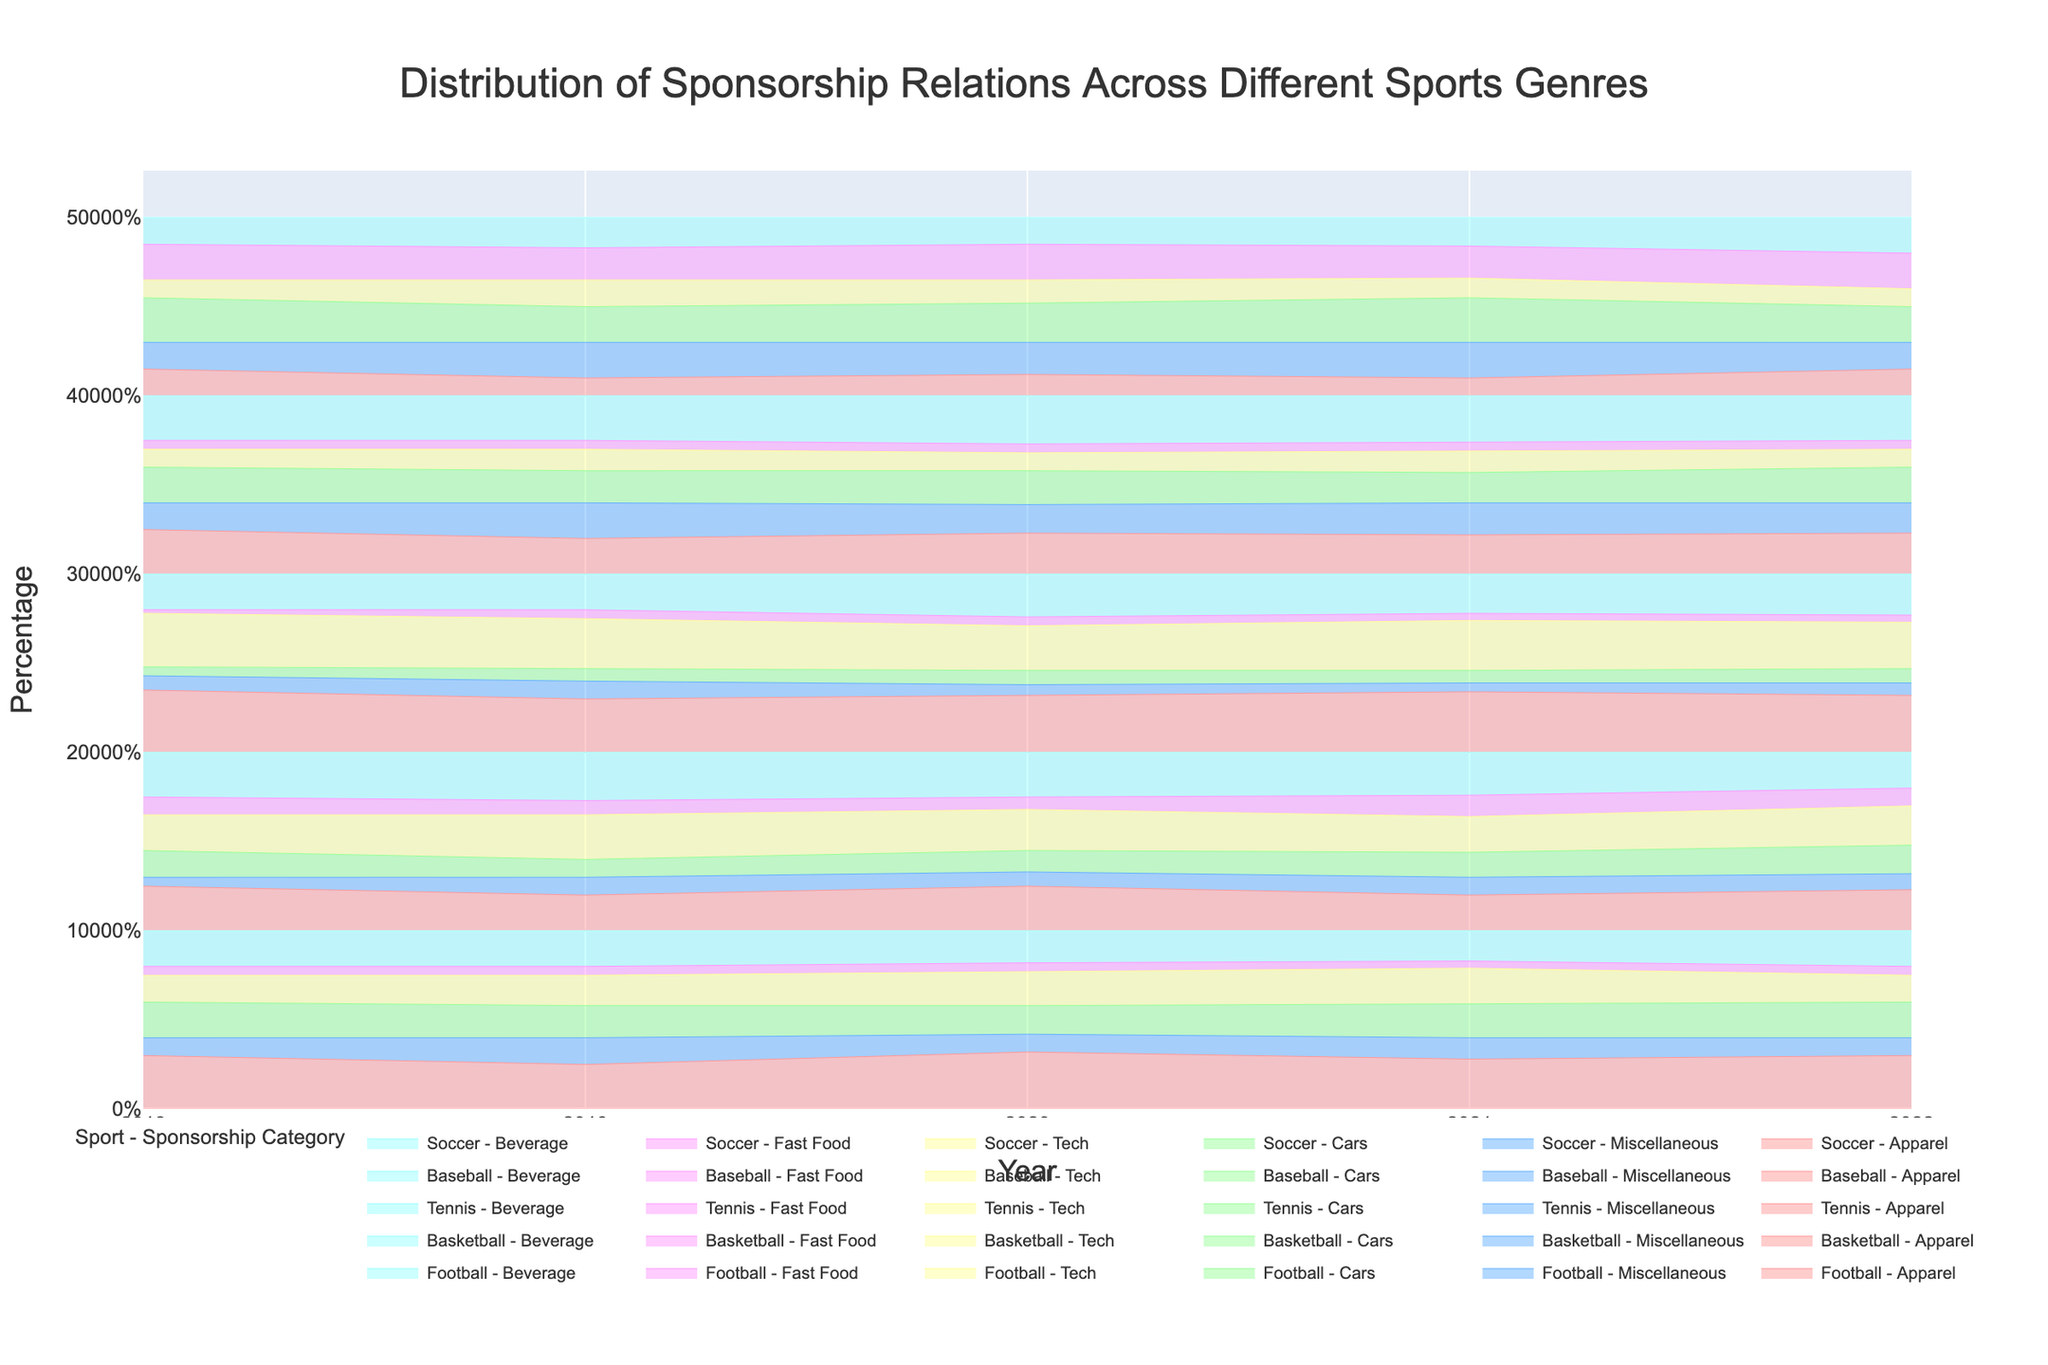How many different sponsorship categories are represented in the plot? The title mentions "Distribution of Sponsorship Relations Across Different Sports Genres," and in the plot, there are clearly several distinct colored areas stacked on top of each other. The legend will typically indicate how many categories are present, which are: Apparel, Miscellaneous, Cars, Tech, Fast Food, and Beverage.
Answer: 6 Which sport had the highest proportion of 'Tech' sponsorship in 2019? By examining the plot, locate the segments corresponding to 'Tech' sponsorship for each sport in 2019. Verify which sport's 'Tech' segment reaches the highest point on the stacked area chart.
Answer: Basketball How did the proportion of 'Apparel' sponsorship in Tennis change from 2018 to 2022? Find the 'Apparel' layers for Tennis in 2018 and 2022 on the plot and compare their heights. The visual stacking will show whether it increased, decreased, or remained the same.
Answer: Decreased What is the general trend in 'Fast Food' sponsorship across all sports between 2018 and 2022? Observe the 'Fast Food' layers across all sports over the years 2018 to 2022. Determine if there is an overall increasing, decreasing, or stable trend. Sum up the proportions for an aggregated view if necessary.
Answer: Relatively stable Comparing Football and Soccer, which sport generally had a higher proportion of 'Cars' sponsorship from 2018 to 2022? Review the 'Cars' layers of both Football and Soccer for each year from 2018 to 2022. Summarize the proportions visually to identify which sport has larger 'Cars' segments overall.
Answer: Soccer In which year did Baseball experience the highest proportion of 'Miscellaneous' sponsorship? Inspect the 'Miscellaneous' sponsorship layer for Baseball across all years and identify the peak proportion.
Answer: 2019 Did 'Beverage' sponsorship in Soccer increase or decrease from 2018 to 2022? Look at the 'Beverage' layer for Soccer in both 2018 and 2022 and compare their heights to determine any increase or decrease.
Answer: Increase Which sponsorship category saw the least variation in Football from 2018 to 2022? Compare the different sponsorship categories in Football from 2018 to 2022 and identify the one with the smallest changes in proportion over the years.
Answer: Fast Food What was the trend in 'Cars' sponsorship for Basketball between 2018 and 2022? Track the 'Cars' sponsorship layer for Basketball from 2018 to 2022. Analyze if the trend was increasing, decreasing, or stable.
Answer: Increased 